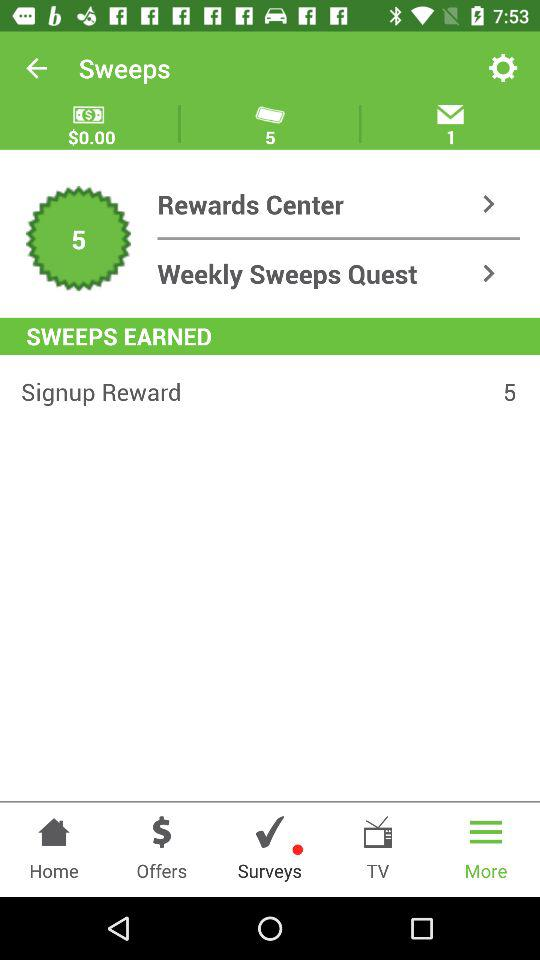How many unread messages are there? There is 1 unread message. 